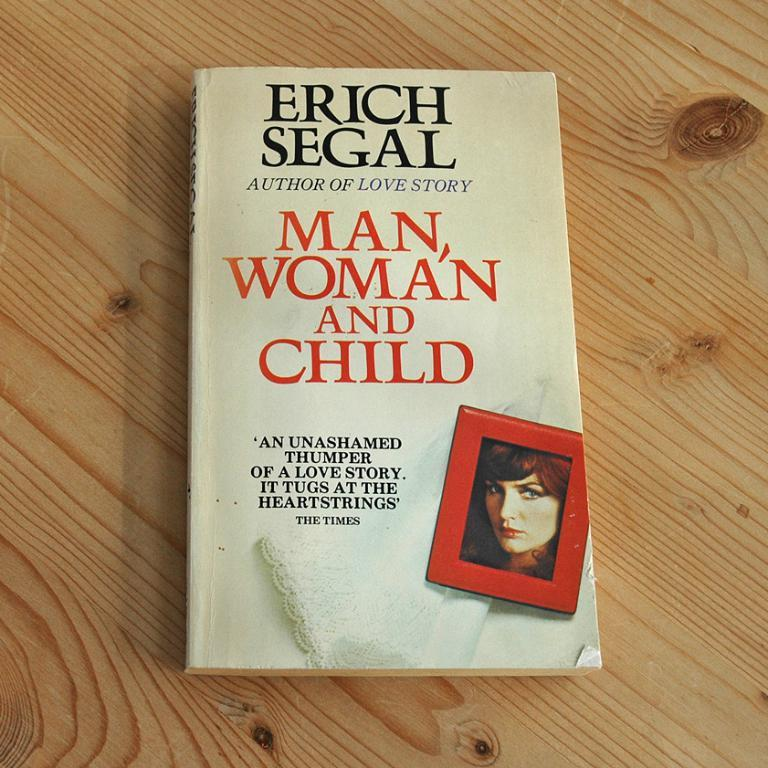What is the main object in the image? There is a book in the image. On what surface is the book placed? The book is placed on a wooden surface. What can be found on the book? There is text and an image of a person on the book. What type of cream is being used to protest in the image? There is no cream or protest present in the image; it features a book with text and an image of a person. 